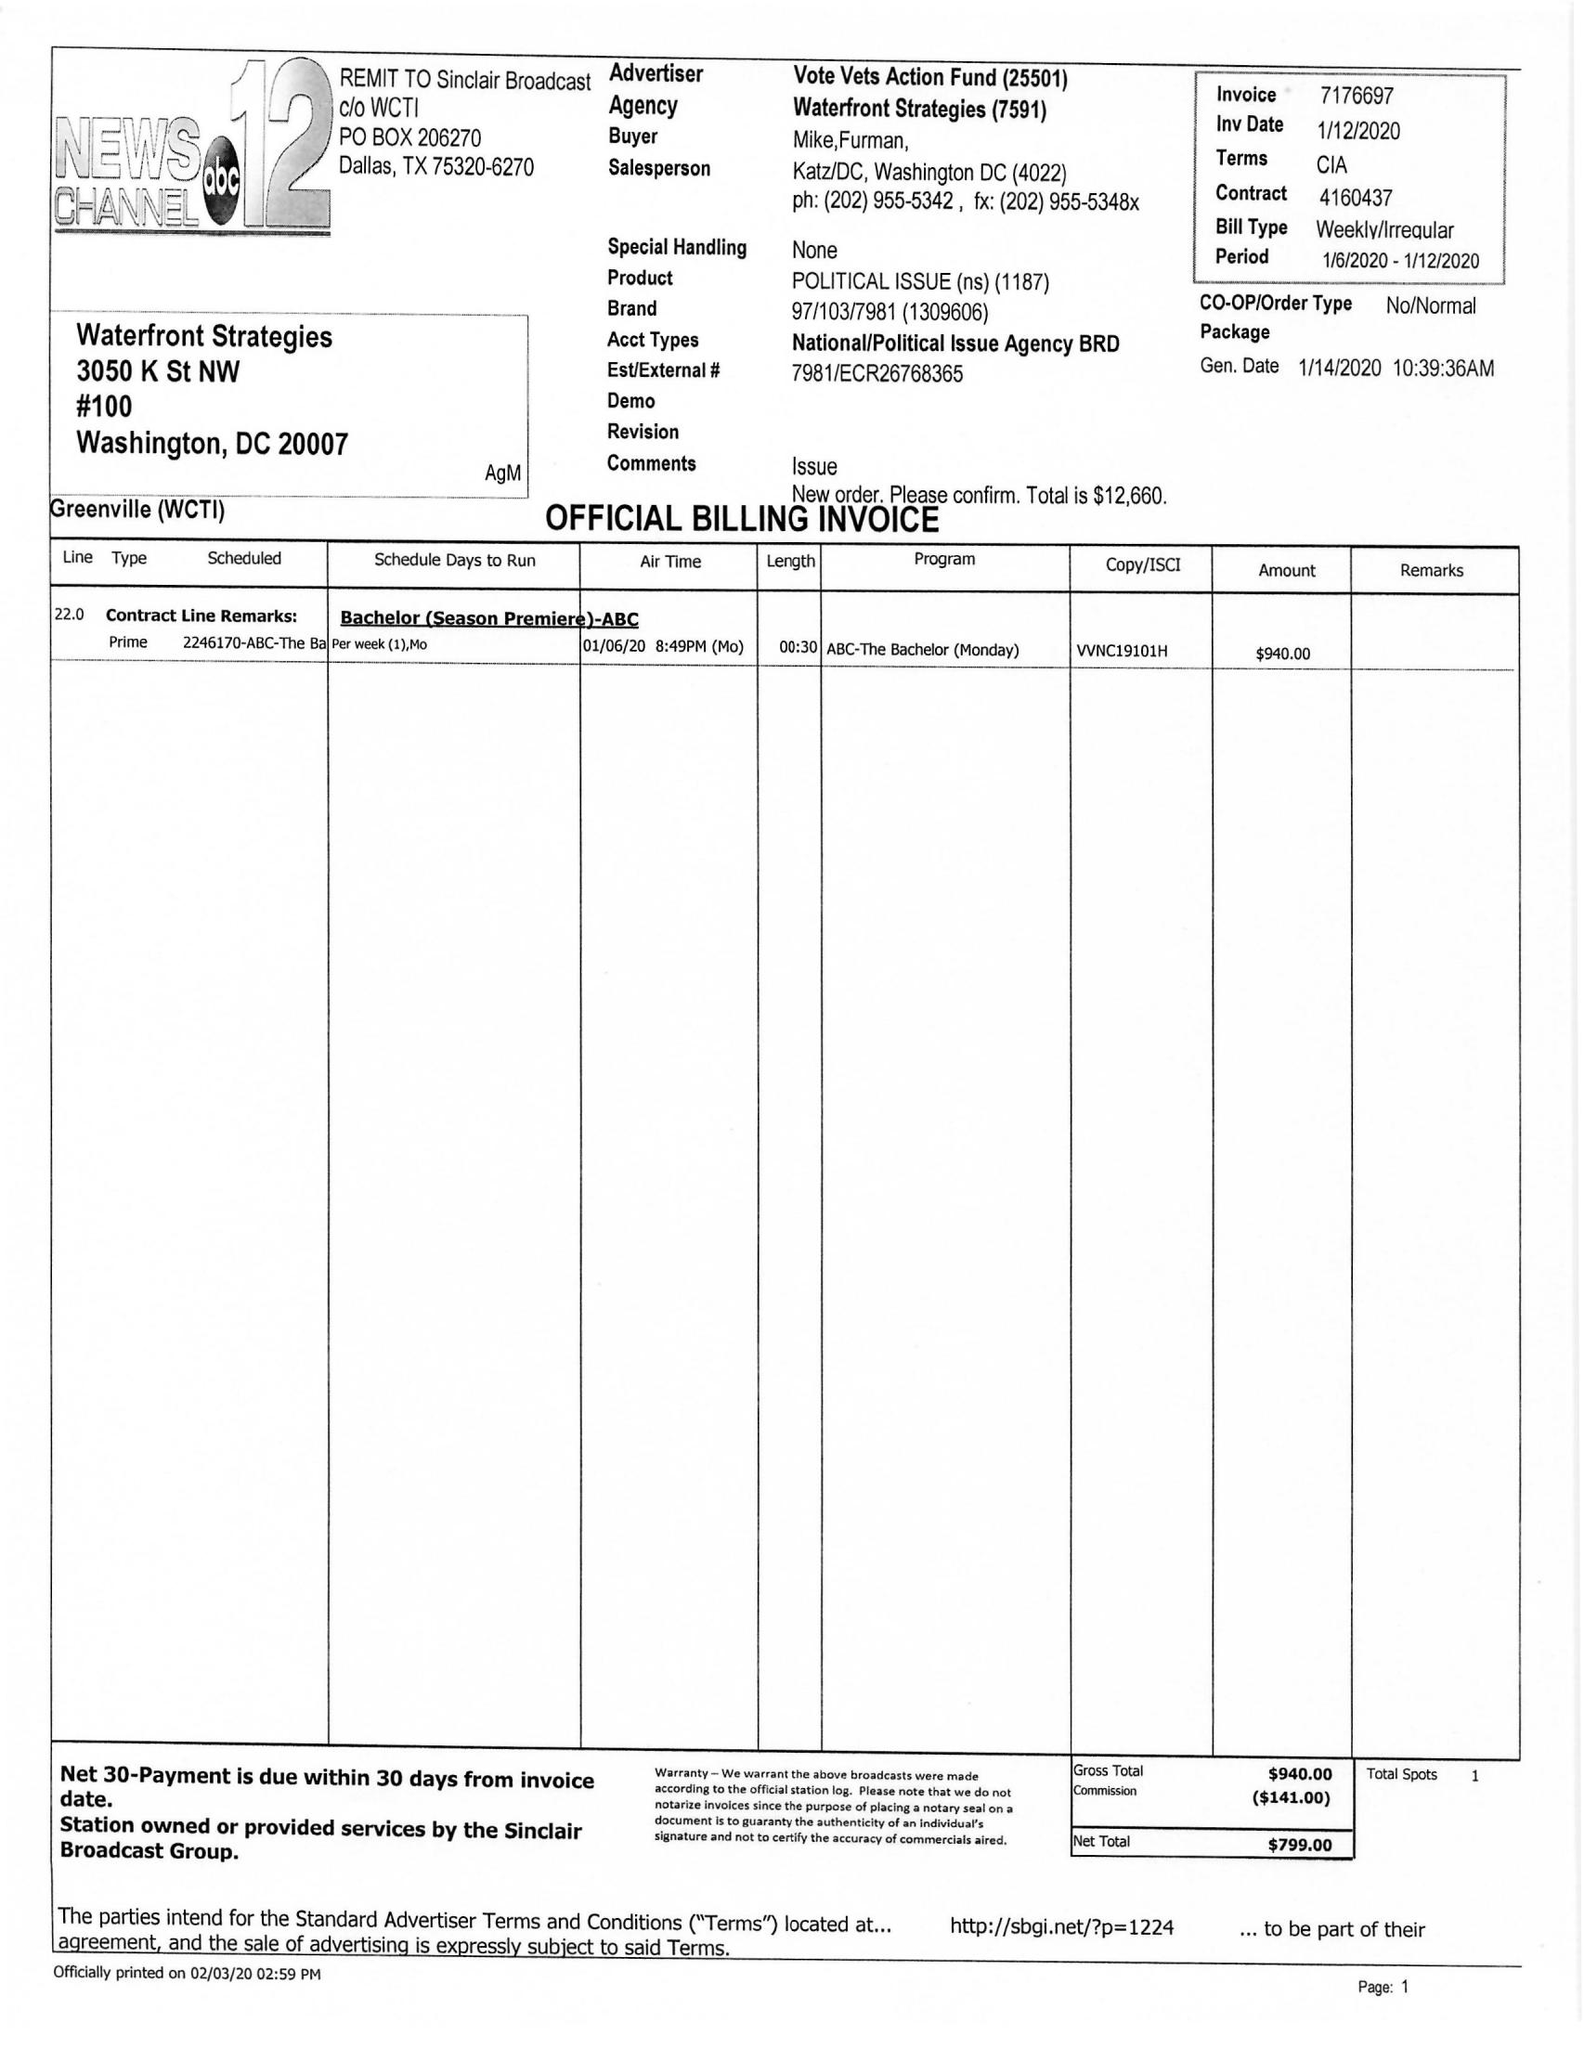What is the value for the flight_from?
Answer the question using a single word or phrase. 01/06/20 